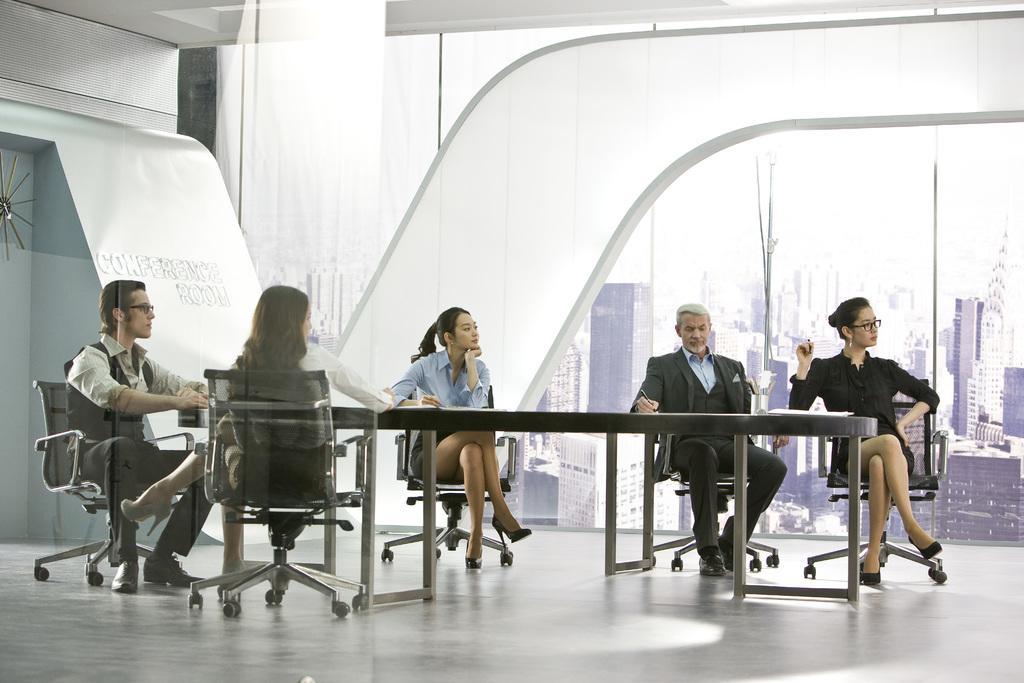In one or two sentences, can you explain what this image depicts? In this image I see 5 persons who are sitting on the chairs and there is a table in front of them. I can also see lot of buildings in the background. 